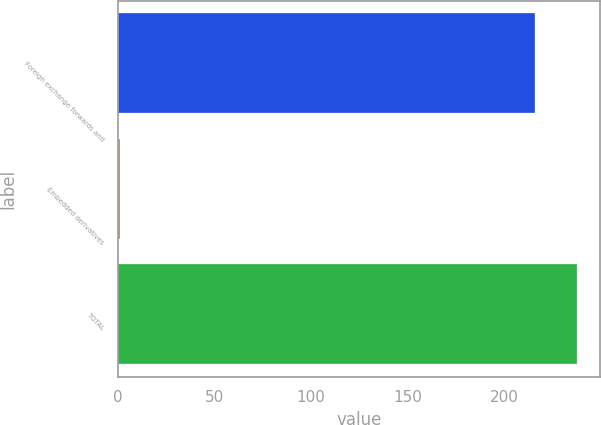Convert chart to OTSL. <chart><loc_0><loc_0><loc_500><loc_500><bar_chart><fcel>Foreign exchange forwards and<fcel>Embedded derivatives<fcel>TOTAL<nl><fcel>216<fcel>1<fcel>237.6<nl></chart> 